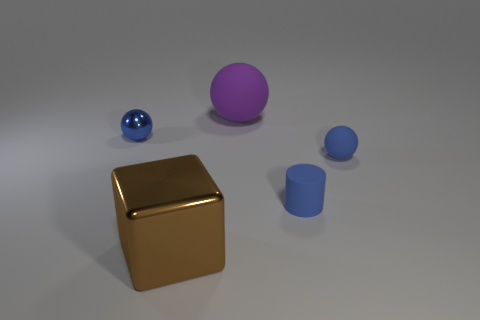Add 3 purple balls. How many objects exist? 8 Subtract all blocks. How many objects are left? 4 Add 4 metal things. How many metal things are left? 6 Add 1 brown metal blocks. How many brown metal blocks exist? 2 Subtract 0 cyan cylinders. How many objects are left? 5 Subtract all brown shiny objects. Subtract all purple spheres. How many objects are left? 3 